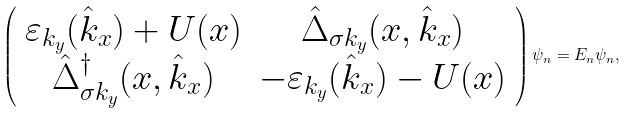<formula> <loc_0><loc_0><loc_500><loc_500>\left ( \begin{array} { c c } \varepsilon _ { k _ { y } } ( \hat { k } _ { x } ) + U ( x ) & \hat { \Delta } _ { \sigma k _ { y } } ( x , \hat { k } _ { x } ) \\ \hat { \Delta } _ { \sigma k _ { y } } ^ { \dag } ( x , \hat { k } _ { x } ) & - \varepsilon _ { k _ { y } } ( \hat { k } _ { x } ) - U ( x ) \end{array} \right ) \psi _ { n } = E _ { n } \psi _ { n } ,</formula> 